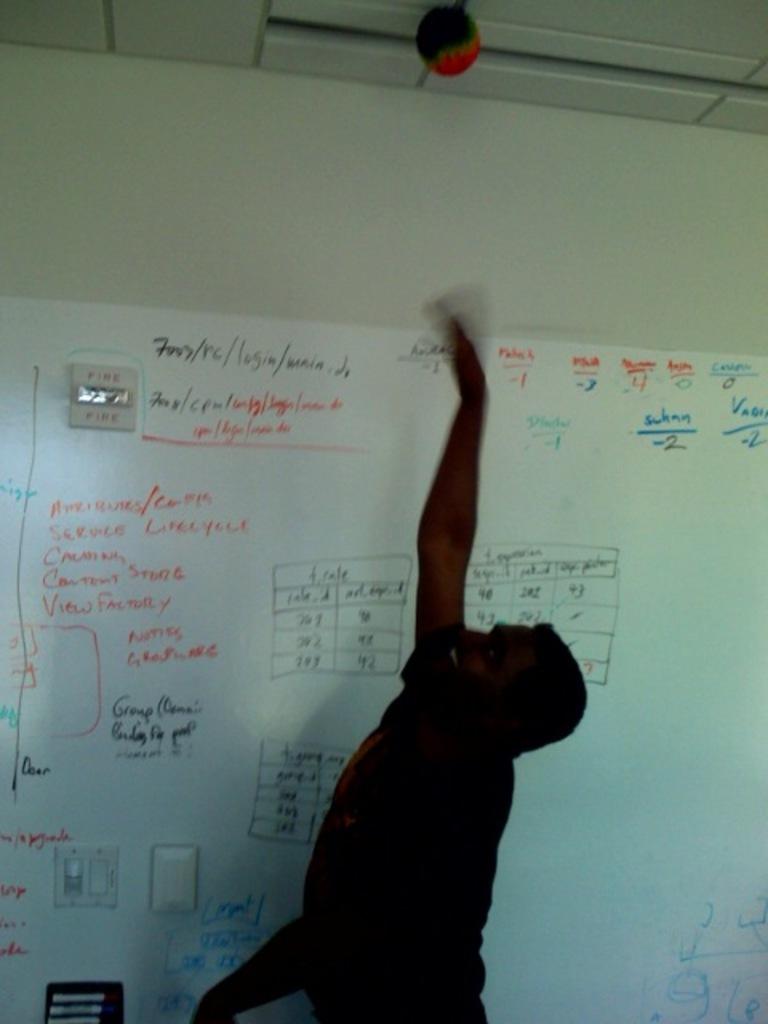Is that a fire alarm to the left?
Provide a short and direct response. Yes. 